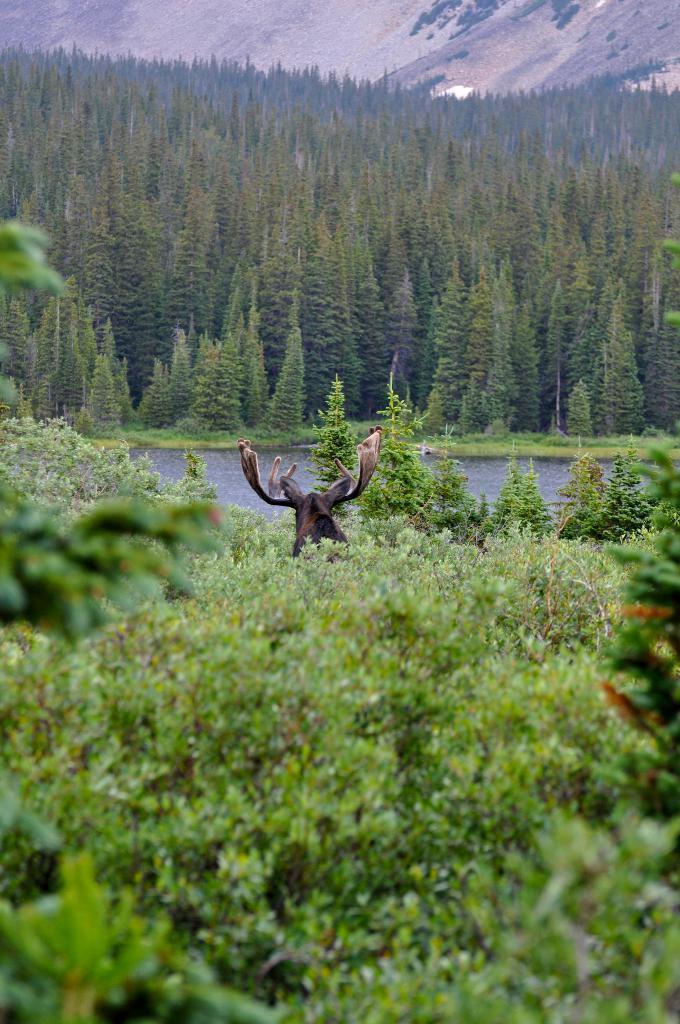How would you summarize this image in a sentence or two? This is an outside view. At the bottom there are many plants. In the middle of the image there is an animal. In the background there is a sea and many trees. At the top of the image there is a hill. 